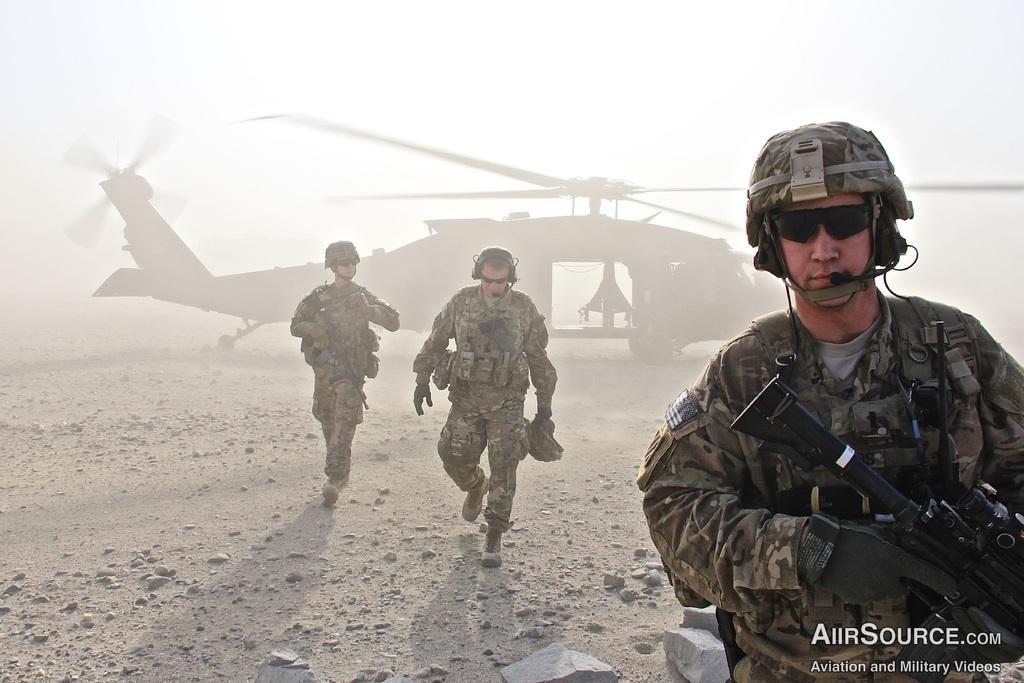Describe this image in one or two sentences. In this image, we can see three people are wearing glasses and holding some objects. In the middle, we can see two people are walking on the ground. Here we can see few stones. Background we can see a helicopter. Right side bottom, we can see some text. 